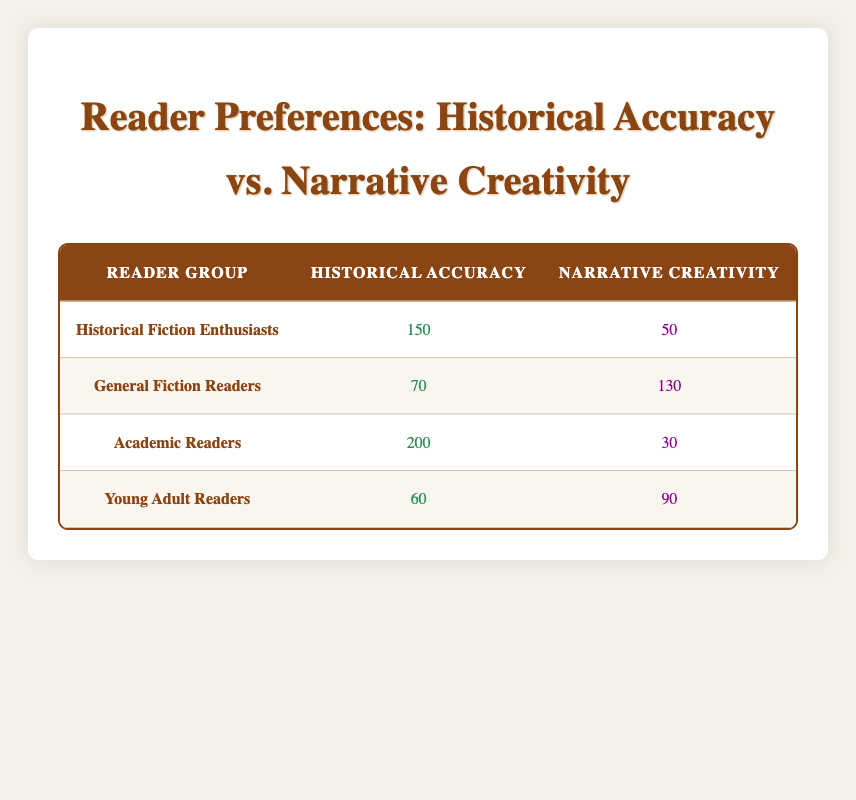What is the count of Historical Fiction Enthusiasts who prefer Historical Accuracy? In the table, under the row for Historical Fiction Enthusiasts, the count for Historical Accuracy is listed as 150.
Answer: 150 What is the total number of General Fiction Readers? To find the total number of General Fiction Readers, we sum the counts for both preferences: 70 (Historical Accuracy) + 130 (Narrative Creativity) = 200.
Answer: 200 Which reader group has the highest preference for Narrative Creativity? Looking at the counts for Narrative Creativity across all groups, the General Fiction Readers have 130, which is higher than the others (50, 30, and 90 for other groups).
Answer: General Fiction Readers Is there a group where the preference for Historical Accuracy is greater than 100? Yes, by examining the counts for Historical Accuracy, we see groups like Academic Readers (200) and Historical Fiction Enthusiasts (150) have counts greater than 100.
Answer: Yes What is the difference in preference counts for Narrative Creativity between Academic Readers and Young Adult Readers? The count for Narrative Creativity in Academic Readers is 30, while for Young Adult Readers it is 90. The difference is calculated as 90 - 30 = 60.
Answer: 60 How many total readers prefer Historical Accuracy across all groups? To find the total for Historical Accuracy, we sum the counts: 150 (Historical Fiction Enthusiasts) + 70 (General Fiction Readers) + 200 (Academic Readers) + 60 (Young Adult Readers) = 480.
Answer: 480 Which group has a greater overall preference count when combining both Historical Accuracy and Narrative Creativity? We must look at the total counts for each group: Historical Fiction Enthusiasts (150 + 50 = 200), General Fiction Readers (70 + 130 = 200), Academic Readers (200 + 30 = 230), and Young Adult Readers (60 + 90 = 150). Academic Readers have the greatest overall preference count.
Answer: Academic Readers What percentage of Young Adult Readers prefer Narrative Creativity? The count for Young Adult Readers who prefer Narrative Creativity is 90, and the total number of Young Adult Readers is 60 (Historical Accuracy) + 90 (Narrative Creativity) = 150. The percentage is calculated as (90/150) * 100 = 60%.
Answer: 60% 